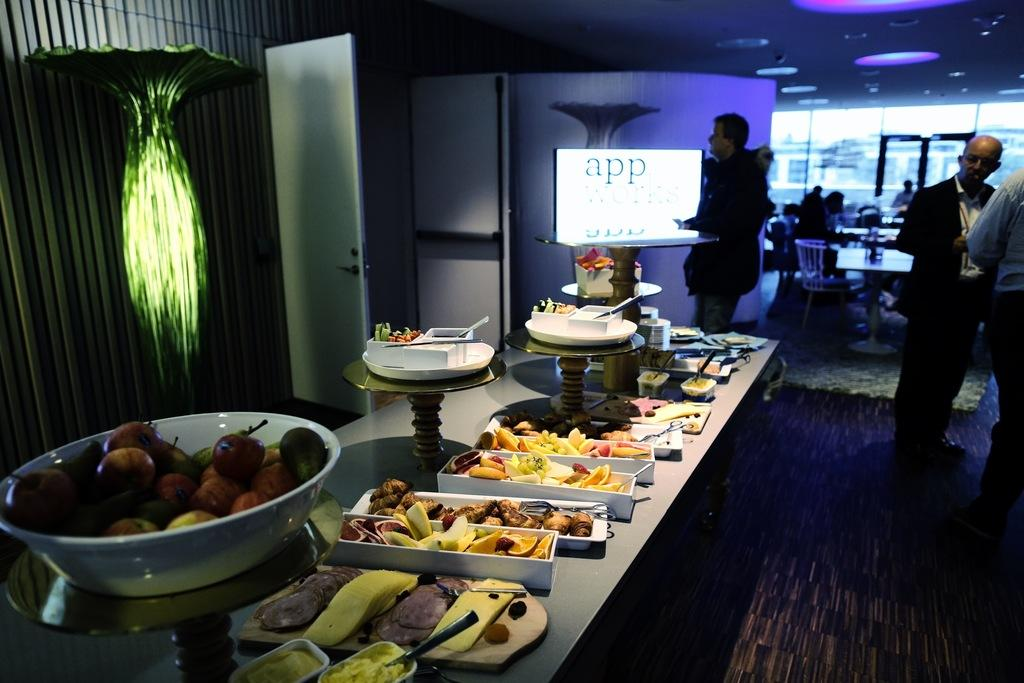What is happening in the image? There are people standing in the image. What is present in the image besides the people? There is a table in the image. What can be found on the table? On the table, there are plates containing food items. What types of food items are on the plates? The food items include fruits, meat, and pastries. What type of railway is visible in the image? There is no railway present in the image. 